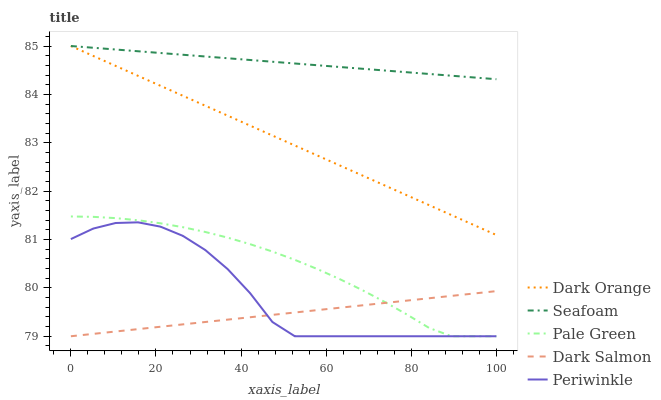Does Dark Salmon have the minimum area under the curve?
Answer yes or no. Yes. Does Seafoam have the maximum area under the curve?
Answer yes or no. Yes. Does Pale Green have the minimum area under the curve?
Answer yes or no. No. Does Pale Green have the maximum area under the curve?
Answer yes or no. No. Is Dark Orange the smoothest?
Answer yes or no. Yes. Is Periwinkle the roughest?
Answer yes or no. Yes. Is Pale Green the smoothest?
Answer yes or no. No. Is Pale Green the roughest?
Answer yes or no. No. Does Seafoam have the lowest value?
Answer yes or no. No. Does Pale Green have the highest value?
Answer yes or no. No. Is Pale Green less than Dark Orange?
Answer yes or no. Yes. Is Seafoam greater than Pale Green?
Answer yes or no. Yes. Does Pale Green intersect Dark Orange?
Answer yes or no. No. 